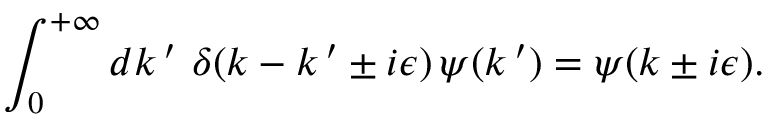Convert formula to latex. <formula><loc_0><loc_0><loc_500><loc_500>\int _ { 0 } ^ { + \infty } d k \, ^ { \prime } \, \delta ( k - k \, ^ { \prime } \pm i \epsilon ) \, \psi ( k \, ^ { \prime } ) = \psi ( k \pm i \epsilon ) .</formula> 